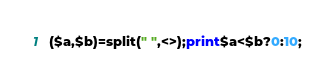Convert code to text. <code><loc_0><loc_0><loc_500><loc_500><_Perl_>($a,$b)=split(" ",<>);print$a<$b?0:10;</code> 